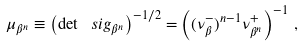Convert formula to latex. <formula><loc_0><loc_0><loc_500><loc_500>\mu _ { \beta ^ { n } } \equiv \left ( \det \ s i g _ { \beta ^ { n } } \right ) ^ { - 1 / 2 } = \left ( ( \nu _ { \beta } ^ { - } ) ^ { n - 1 } \nu _ { \beta ^ { n } } ^ { + } \right ) ^ { - 1 } \, ,</formula> 